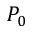<formula> <loc_0><loc_0><loc_500><loc_500>P _ { 0 }</formula> 